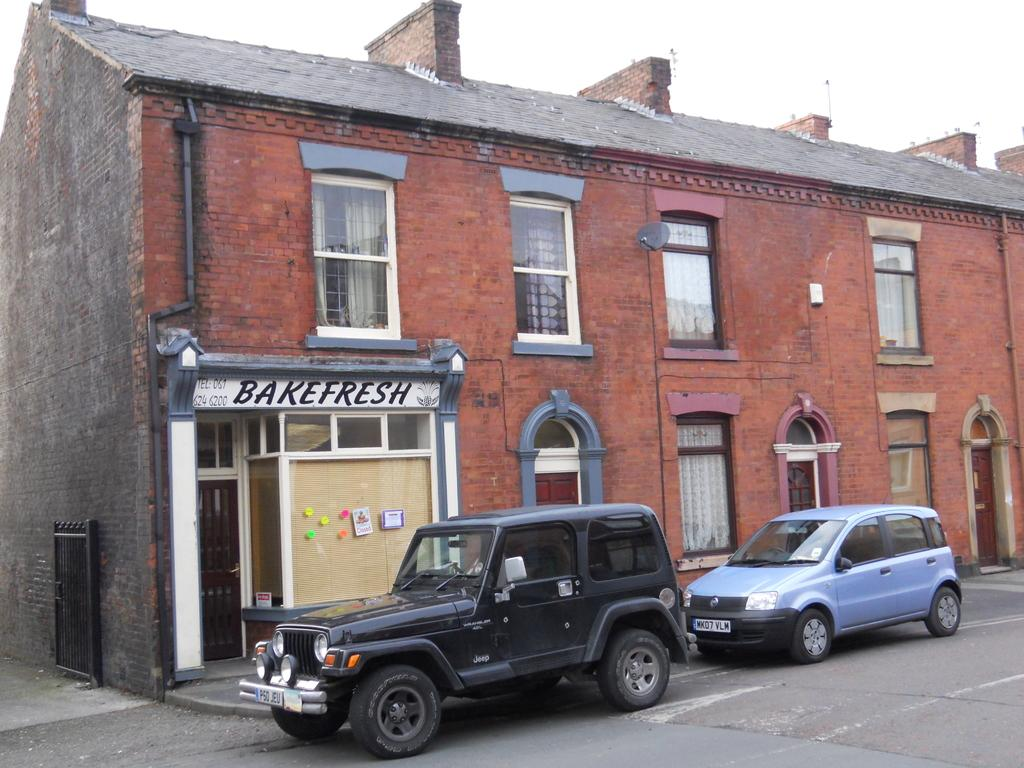What can be seen on the road in the image? There are two vehicles on the road in the image. What is located on the left side of the image? There is a store on the left side of the image. What type of structure is present in the image? There is a building in the image. What is visible at the top of the image? The sky is visible at the top of the image. What type of wool is being spun by the finger in the image? There is no wool or finger present in the image. How many circles can be seen in the image? There are no circles visible in the image. 